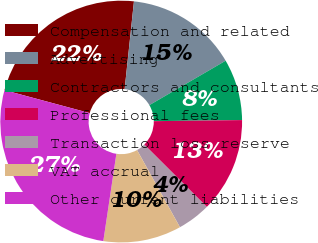Convert chart to OTSL. <chart><loc_0><loc_0><loc_500><loc_500><pie_chart><fcel>Compensation and related<fcel>Advertising<fcel>Contractors and consultants<fcel>Professional fees<fcel>Transaction loss reserve<fcel>VAT accrual<fcel>Other current liabilities<nl><fcel>22.5%<fcel>14.92%<fcel>8.2%<fcel>12.68%<fcel>4.44%<fcel>10.44%<fcel>26.82%<nl></chart> 